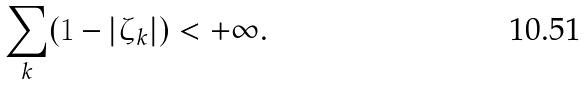<formula> <loc_0><loc_0><loc_500><loc_500>\sum _ { k } ( 1 - | \zeta _ { k } | ) < + \infty .</formula> 